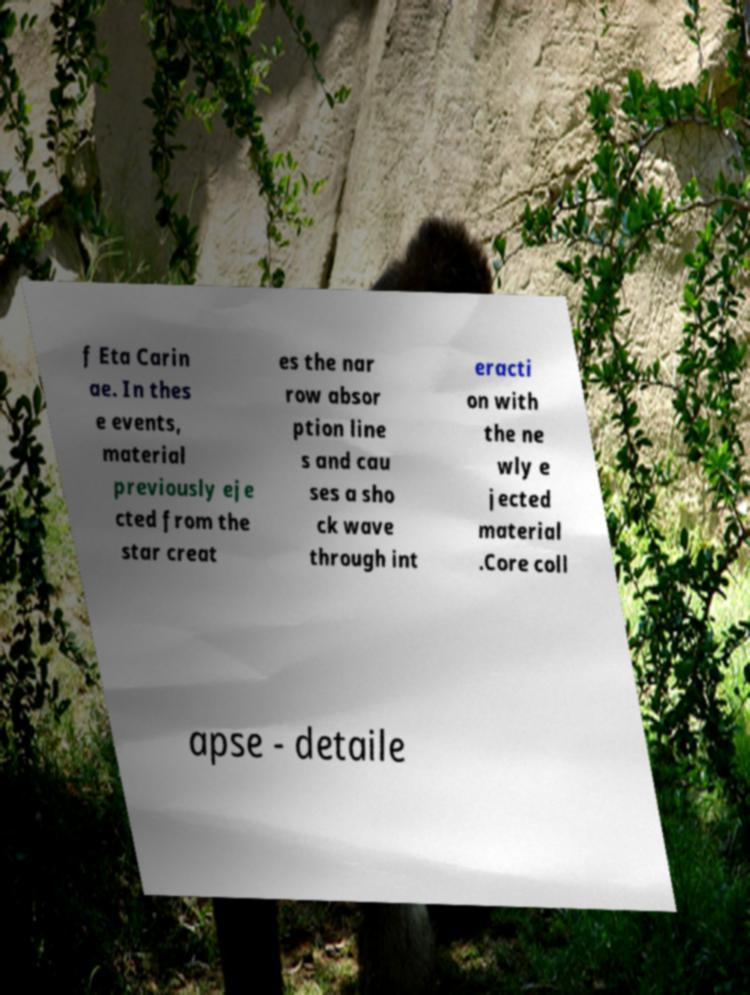What messages or text are displayed in this image? I need them in a readable, typed format. f Eta Carin ae. In thes e events, material previously eje cted from the star creat es the nar row absor ption line s and cau ses a sho ck wave through int eracti on with the ne wly e jected material .Core coll apse - detaile 